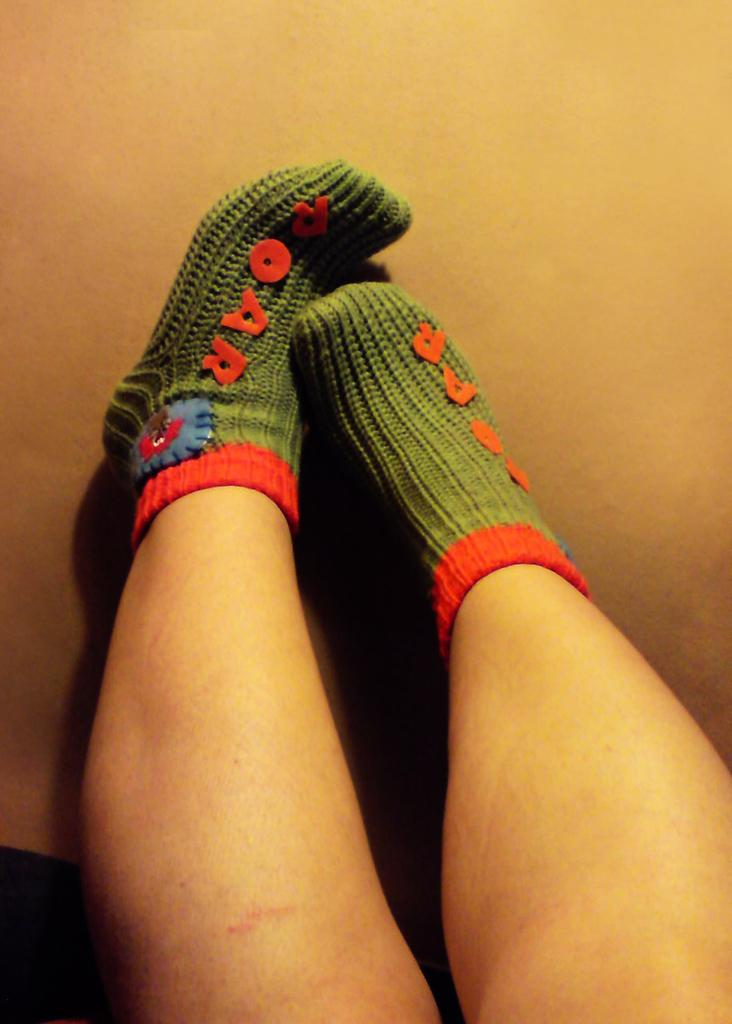What is present on the legs in the image? There are two legs in the image. What can be seen on the socks of the legs? The socks on the legs have green and red colors, and there is some text visible on the socks. What is located on the floor in the image? There is an object on the floor in the image. What additional detail can be observed on the socks? There is a sticker on the socks. How many birds are perched on the legs in the image? There are no birds present in the image; it only features legs with socks. What type of lead is being used to draw the text on the socks? There is no indication that the text on the socks was drawn with any type of lead; it is likely printed or woven into the fabric. 